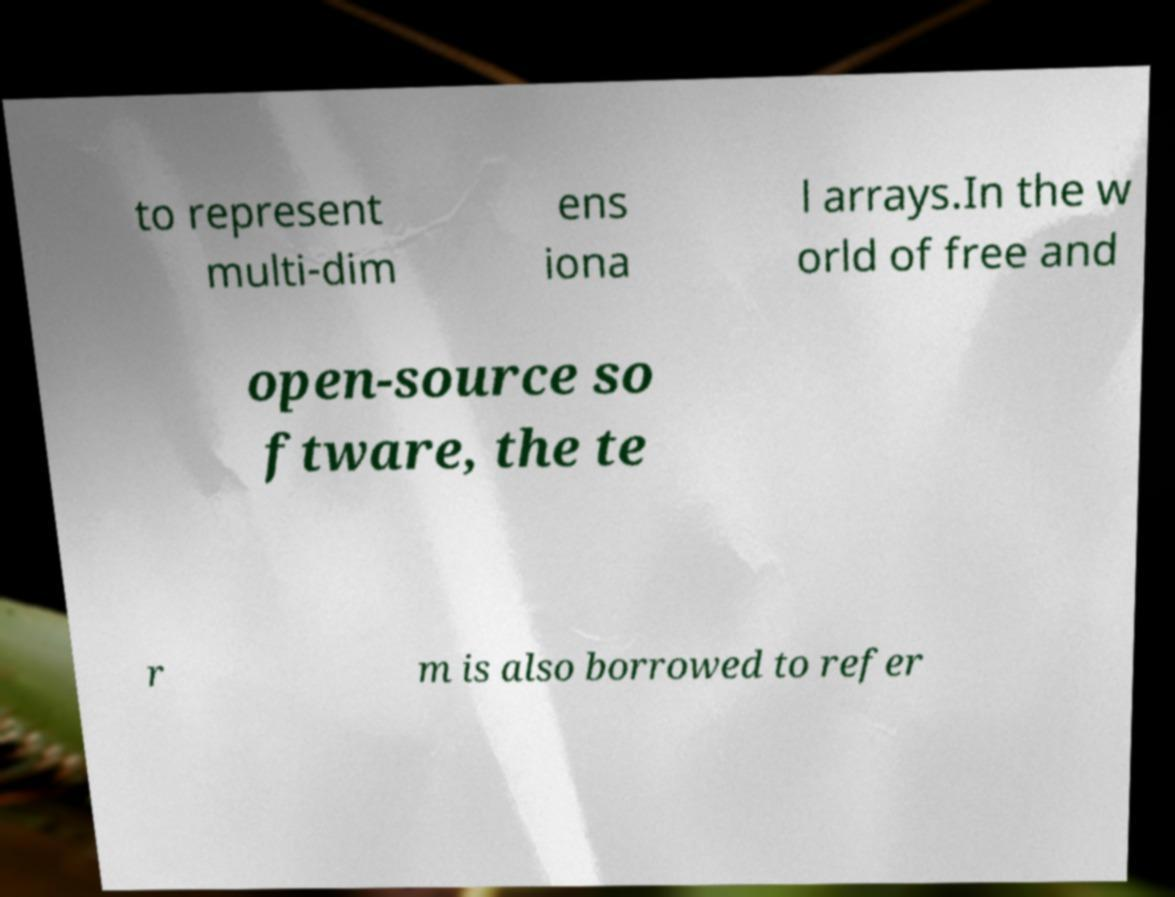Could you assist in decoding the text presented in this image and type it out clearly? to represent multi-dim ens iona l arrays.In the w orld of free and open-source so ftware, the te r m is also borrowed to refer 